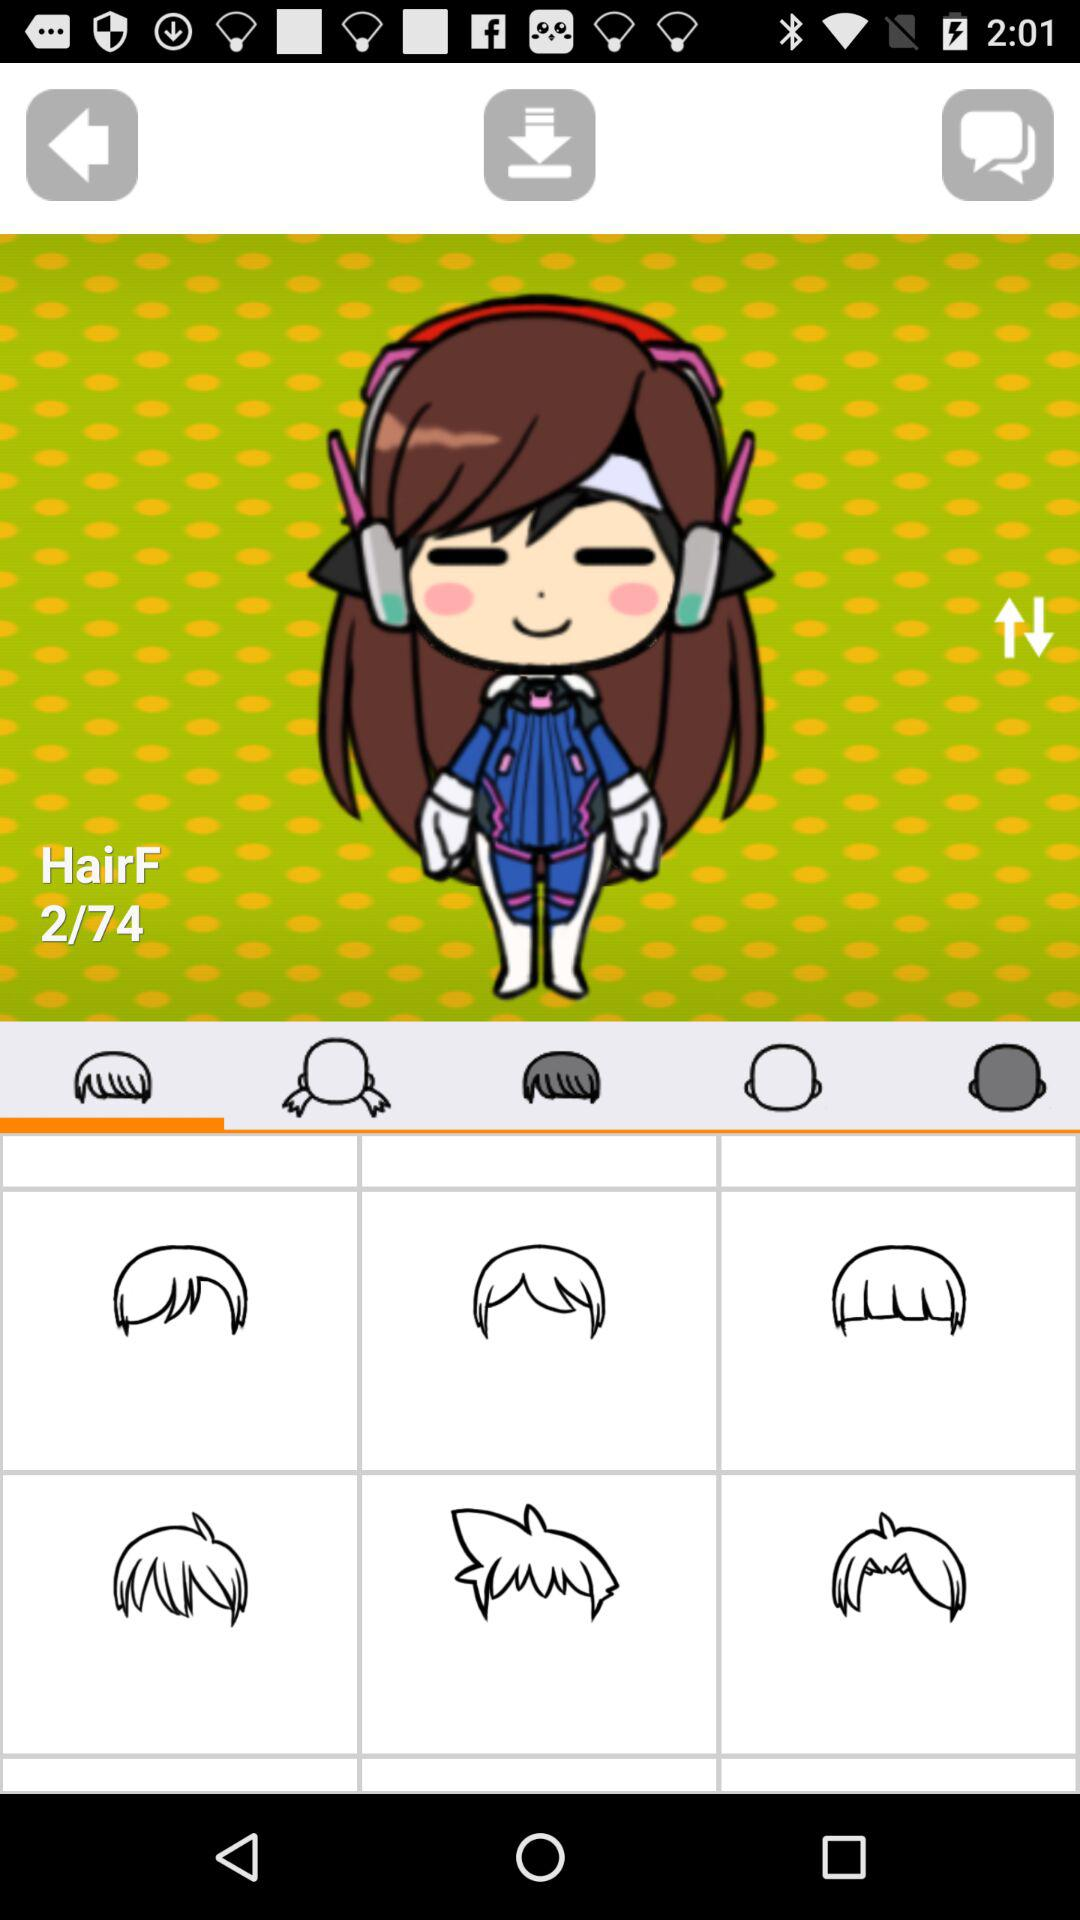How many hair images in total are there? There are 74 hair images in total. 